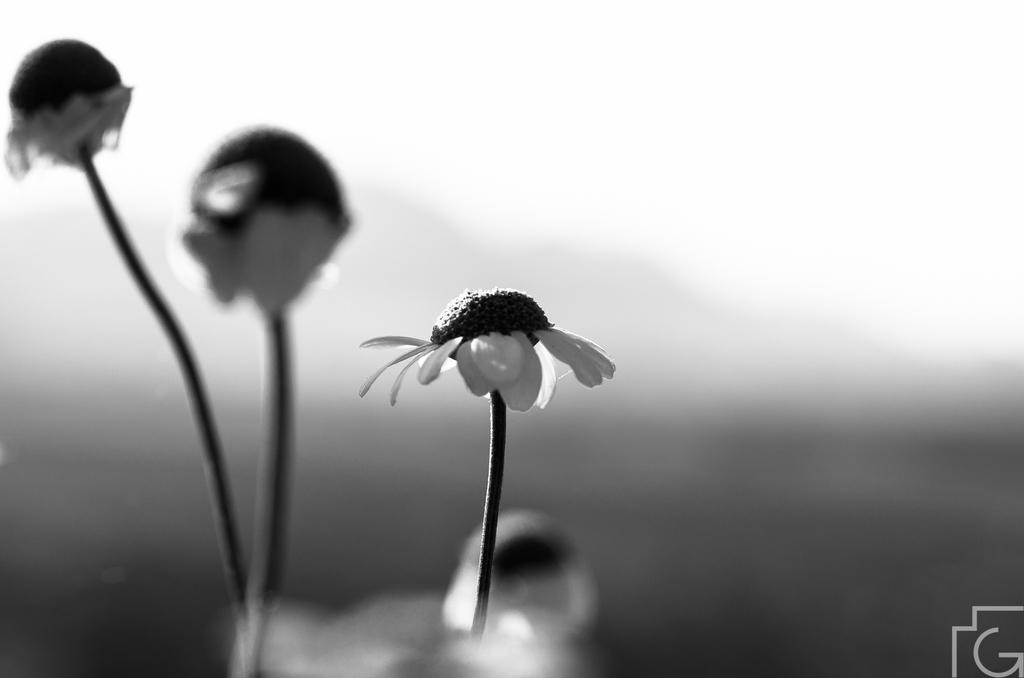What is the color scheme of the photograph? The photograph is black and white. What type of flora is present in the photograph? The photograph contains small flowers. How is the background of the photograph depicted? The background of the photograph is blurred. What is the manager's opinion on the line in the photograph? There is no line, manager or manager present in the photograph, so it is not possible to determine their opinion. 